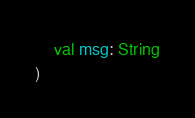<code> <loc_0><loc_0><loc_500><loc_500><_Kotlin_>    val msg: String
)</code> 